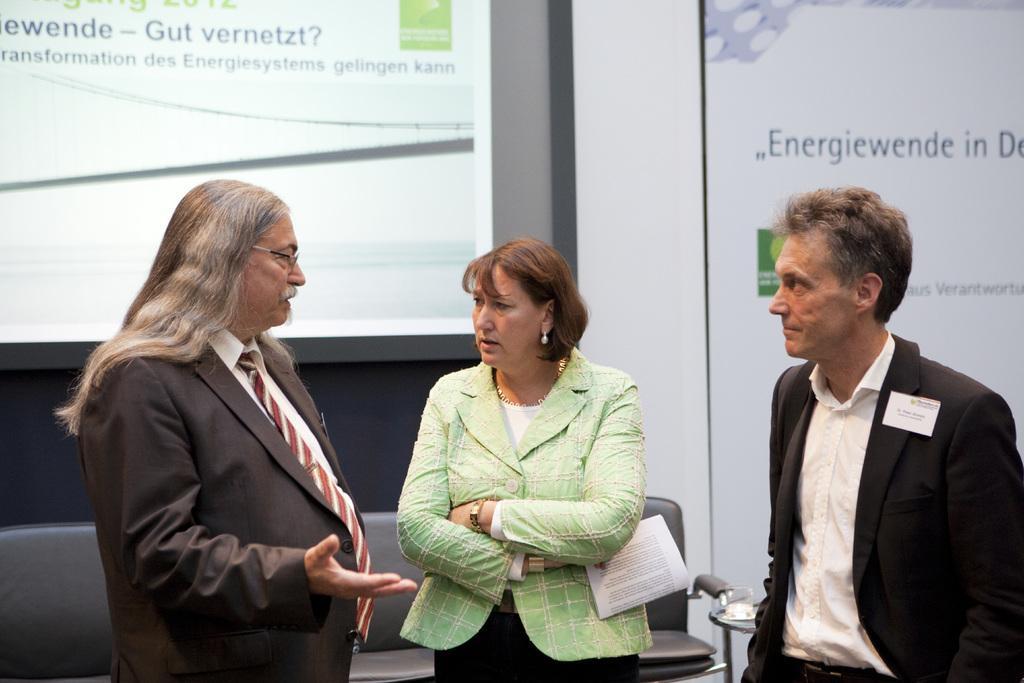Describe this image in one or two sentences. In the center of the image there are three persons. There is a sofa. There is a projector screen in the background of the image. 